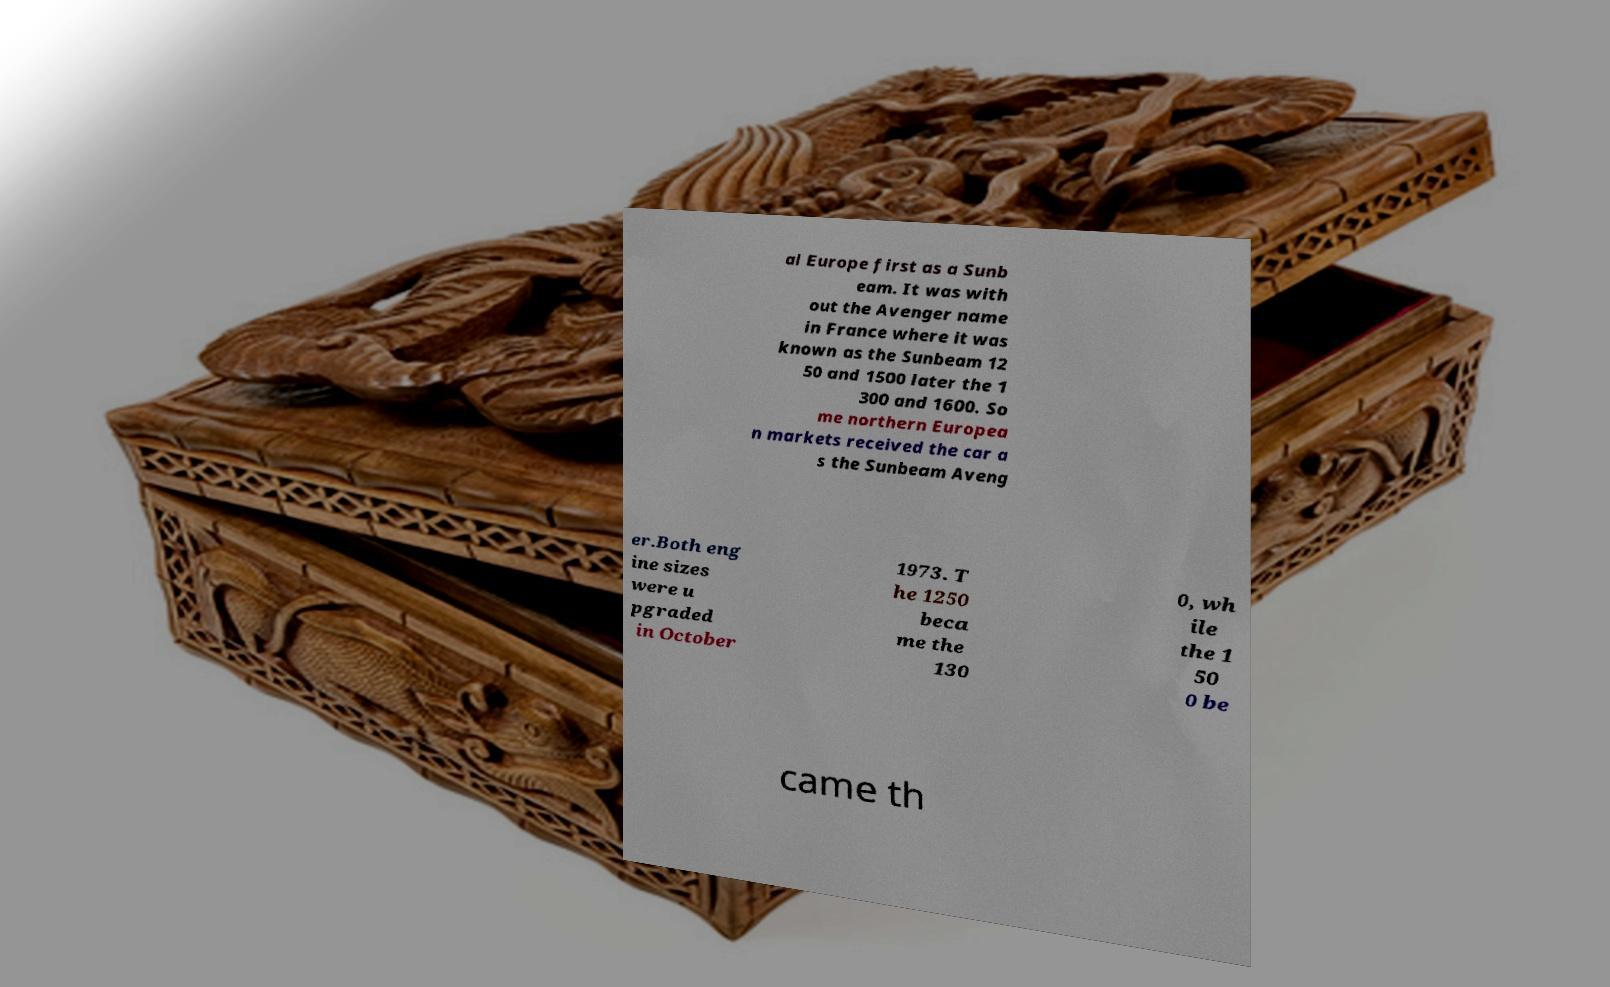There's text embedded in this image that I need extracted. Can you transcribe it verbatim? al Europe first as a Sunb eam. It was with out the Avenger name in France where it was known as the Sunbeam 12 50 and 1500 later the 1 300 and 1600. So me northern Europea n markets received the car a s the Sunbeam Aveng er.Both eng ine sizes were u pgraded in October 1973. T he 1250 beca me the 130 0, wh ile the 1 50 0 be came th 